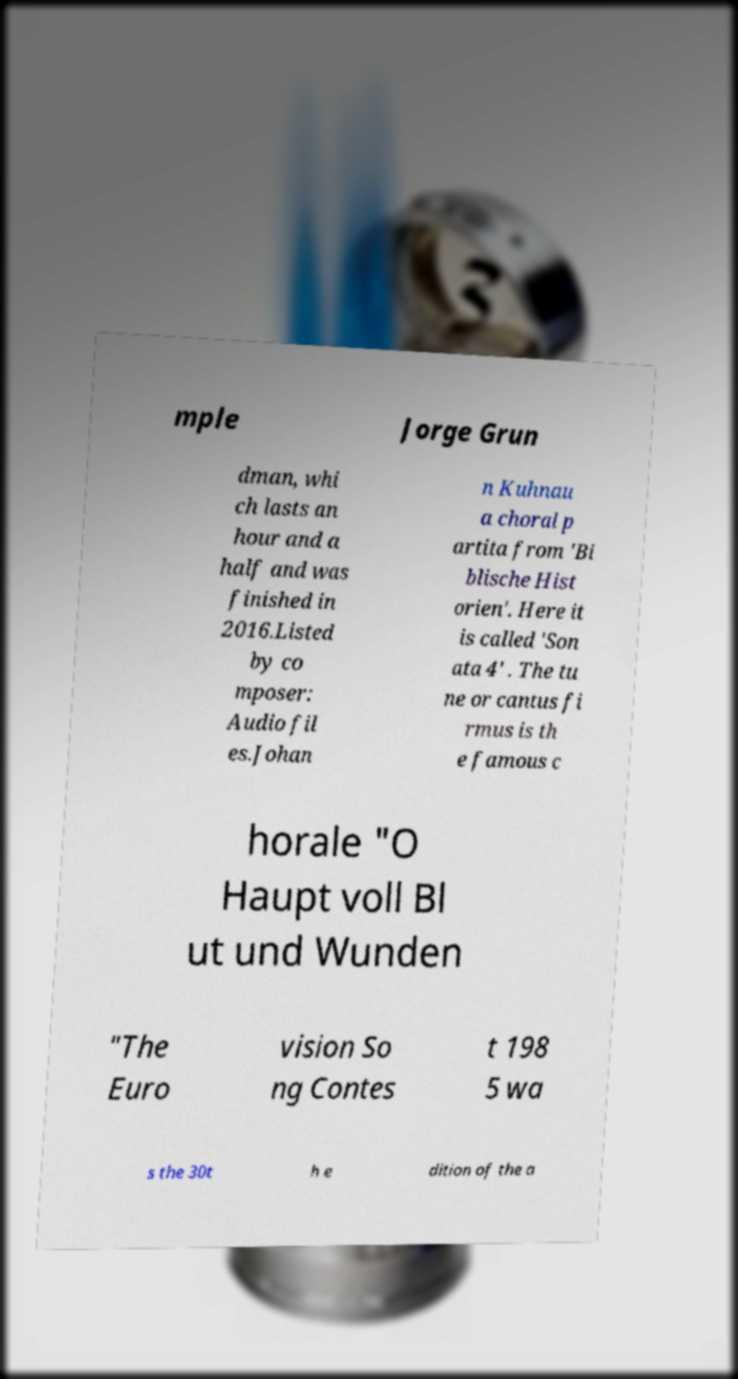Please identify and transcribe the text found in this image. mple Jorge Grun dman, whi ch lasts an hour and a half and was finished in 2016.Listed by co mposer: Audio fil es.Johan n Kuhnau a choral p artita from 'Bi blische Hist orien'. Here it is called 'Son ata 4' . The tu ne or cantus fi rmus is th e famous c horale "O Haupt voll Bl ut und Wunden "The Euro vision So ng Contes t 198 5 wa s the 30t h e dition of the a 